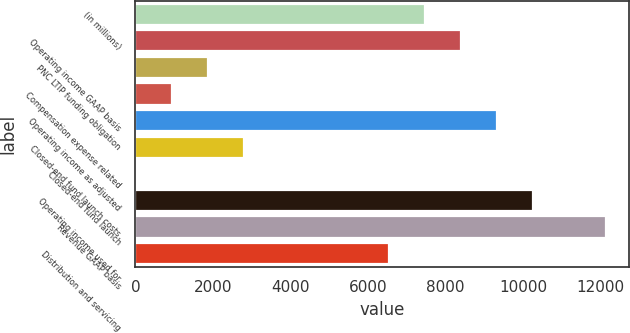Convert chart. <chart><loc_0><loc_0><loc_500><loc_500><bar_chart><fcel>(in millions)<fcel>Operating income GAAP basis<fcel>PNC LTIP funding obligation<fcel>Compensation expense related<fcel>Operating income as adjusted<fcel>Closed-end fund launch costs<fcel>Closed-end fund launch<fcel>Operating income used for<fcel>Revenue GAAP basis<fcel>Distribution and servicing<nl><fcel>7470.2<fcel>8403.6<fcel>1869.8<fcel>936.4<fcel>9337<fcel>2803.2<fcel>3<fcel>10270.4<fcel>12137.2<fcel>6536.8<nl></chart> 